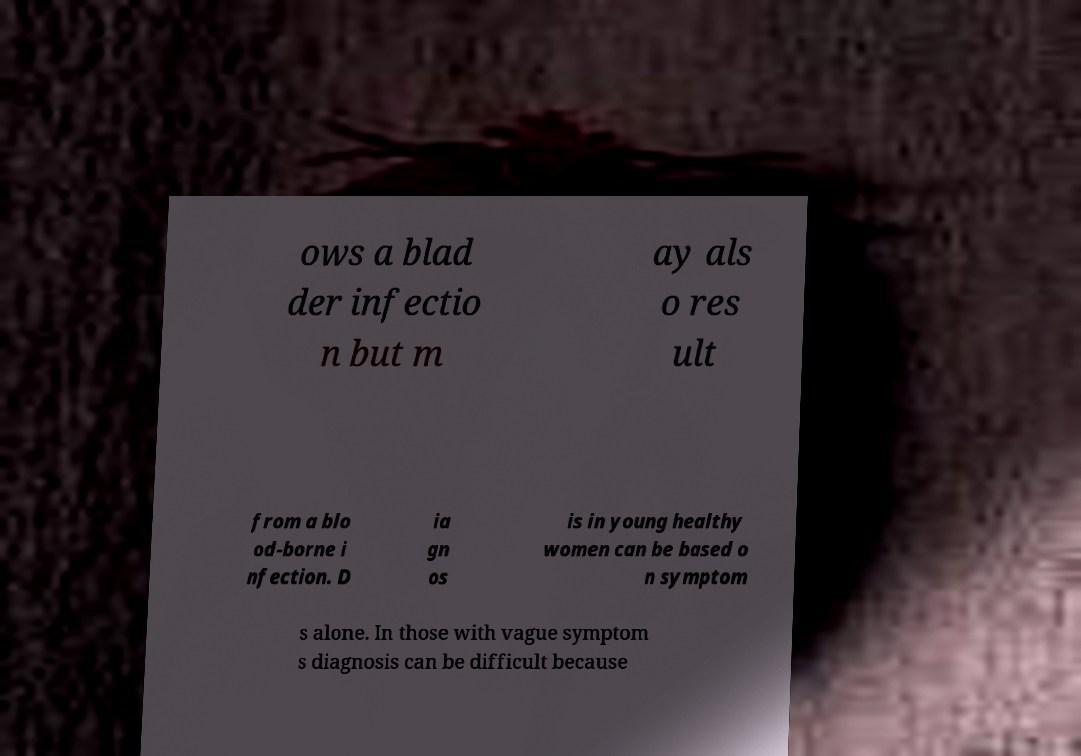Can you accurately transcribe the text from the provided image for me? ows a blad der infectio n but m ay als o res ult from a blo od-borne i nfection. D ia gn os is in young healthy women can be based o n symptom s alone. In those with vague symptom s diagnosis can be difficult because 